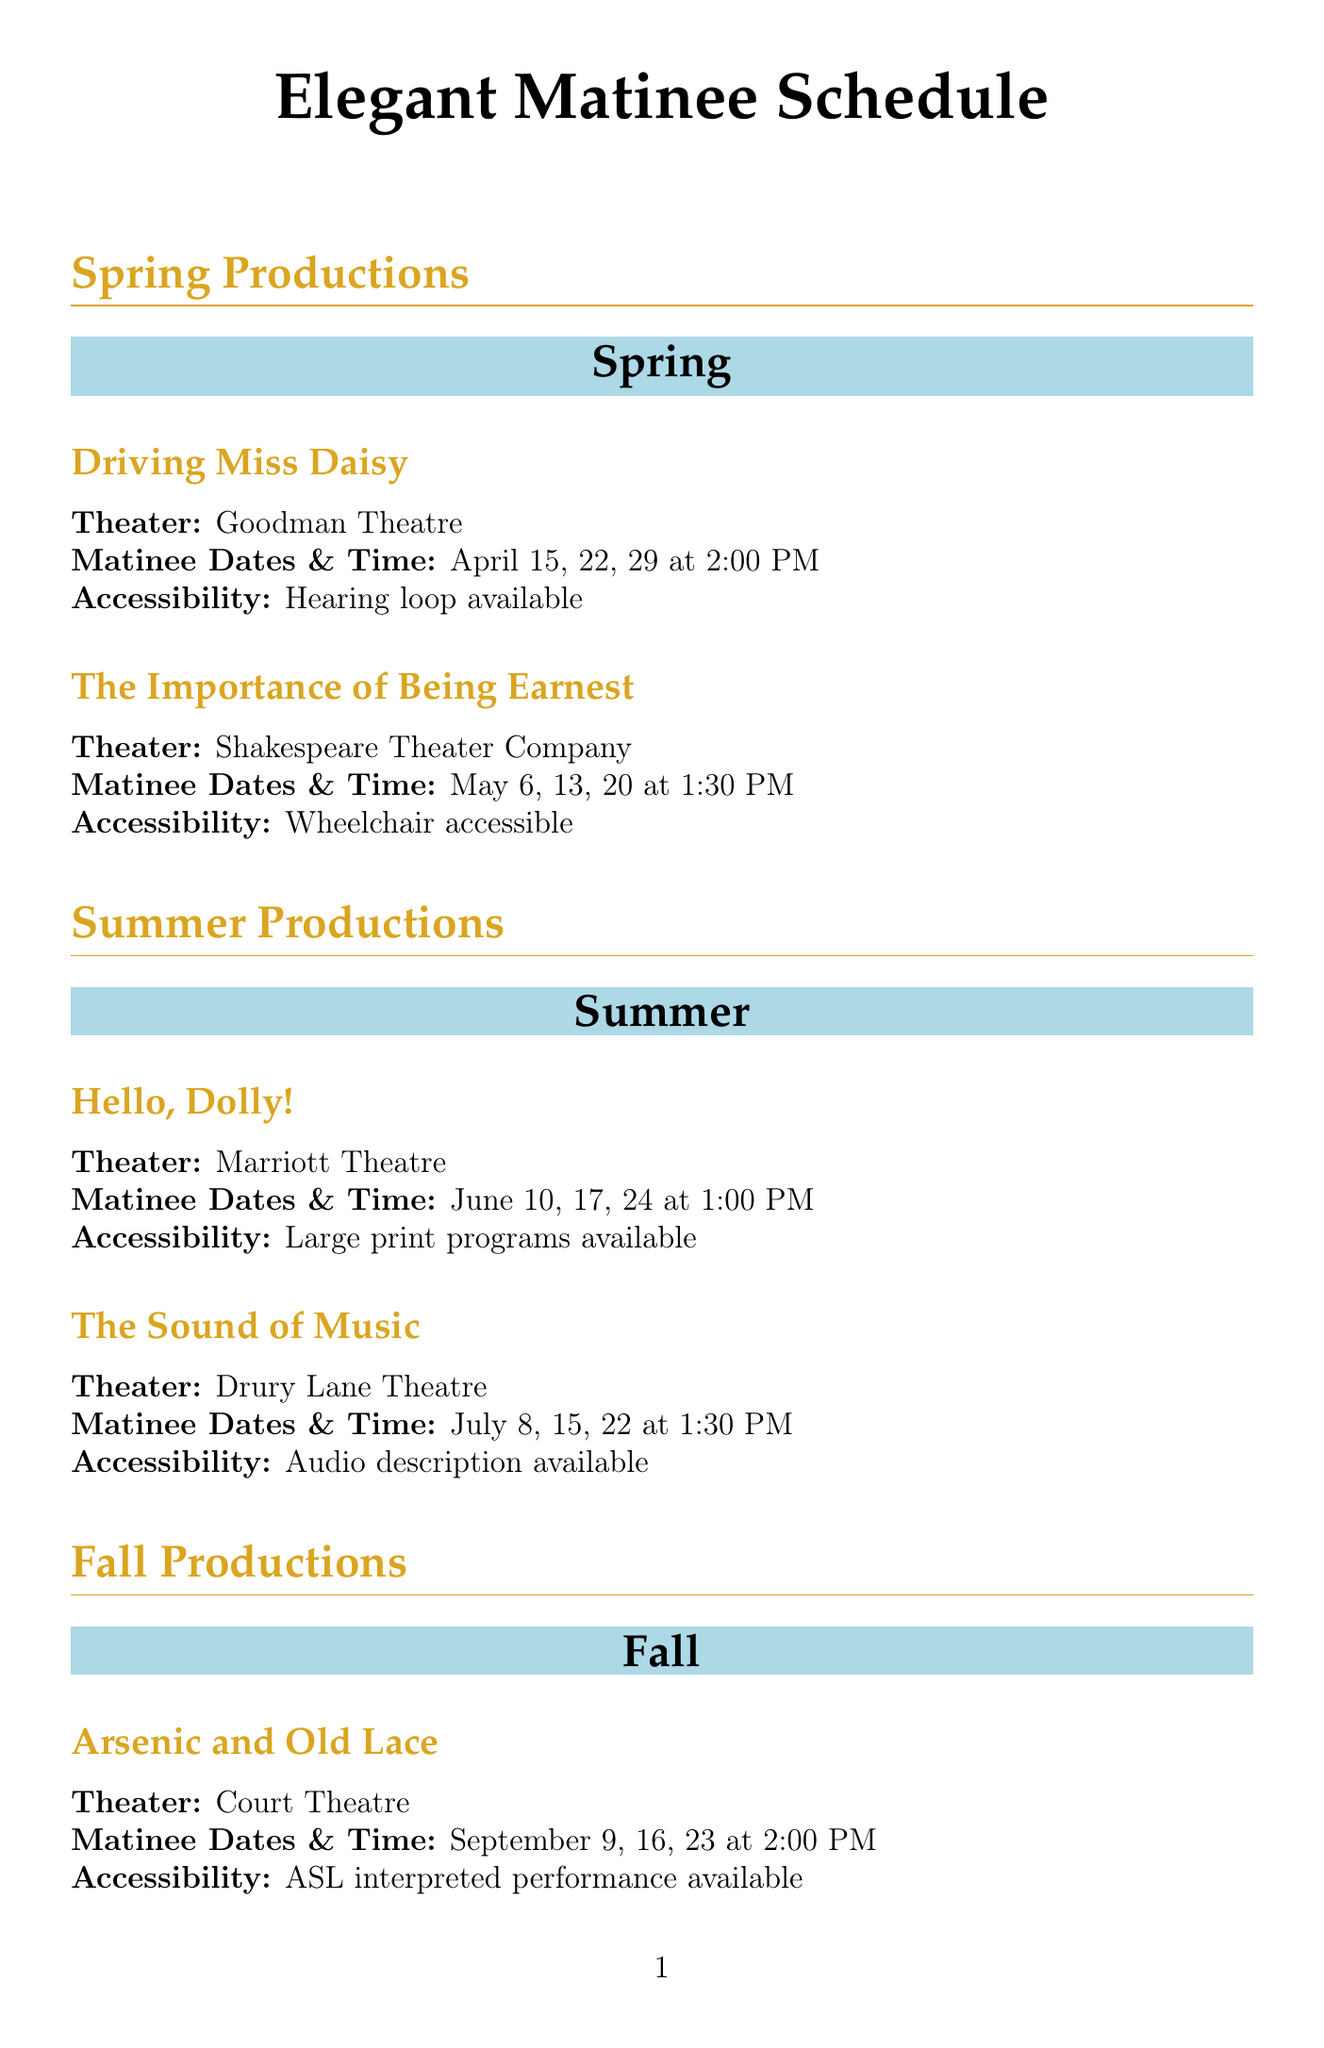what are the matinee dates for "Driving Miss Daisy"? The matinee dates for "Driving Miss Daisy" are listed as April 15, 22, and 29.
Answer: April 15, 22, 29 which theater is hosting "The Sound of Music"? "The Sound of Music" is hosted by Drury Lane Theatre.
Answer: Drury Lane Theatre what time do matinee performances for "The Gin Game" start? The matinee performances for "The Gin Game" start at 3:00 PM.
Answer: 3:00 PM how many productions are scheduled for Summer? The schedule lists two productions for Summer: "Hello, Dolly!" and "The Sound of Music."
Answer: 2 what accessibility feature is available for "A Christmas Carol"? The accessibility feature available for "A Christmas Carol" is a touch tour.
Answer: Touch tour available what is the senior discount availability status for all productions? All productions listed provide a senior discount for attendees.
Answer: true what is offered 45 minutes before each matinee performance? An insightful discussion about the production is offered 45 minutes before each matinee performance.
Answer: Pre-show talks what dining option is available at the theater cafe? The theater cafe offers a senior menu with classic, elegant dishes.
Answer: Senior menu available what discount is available at Timeless Elegance Salon? A 10% discount on updos and styling is available at Timeless Elegance Salon with a ticket stub.
Answer: 10% discount 